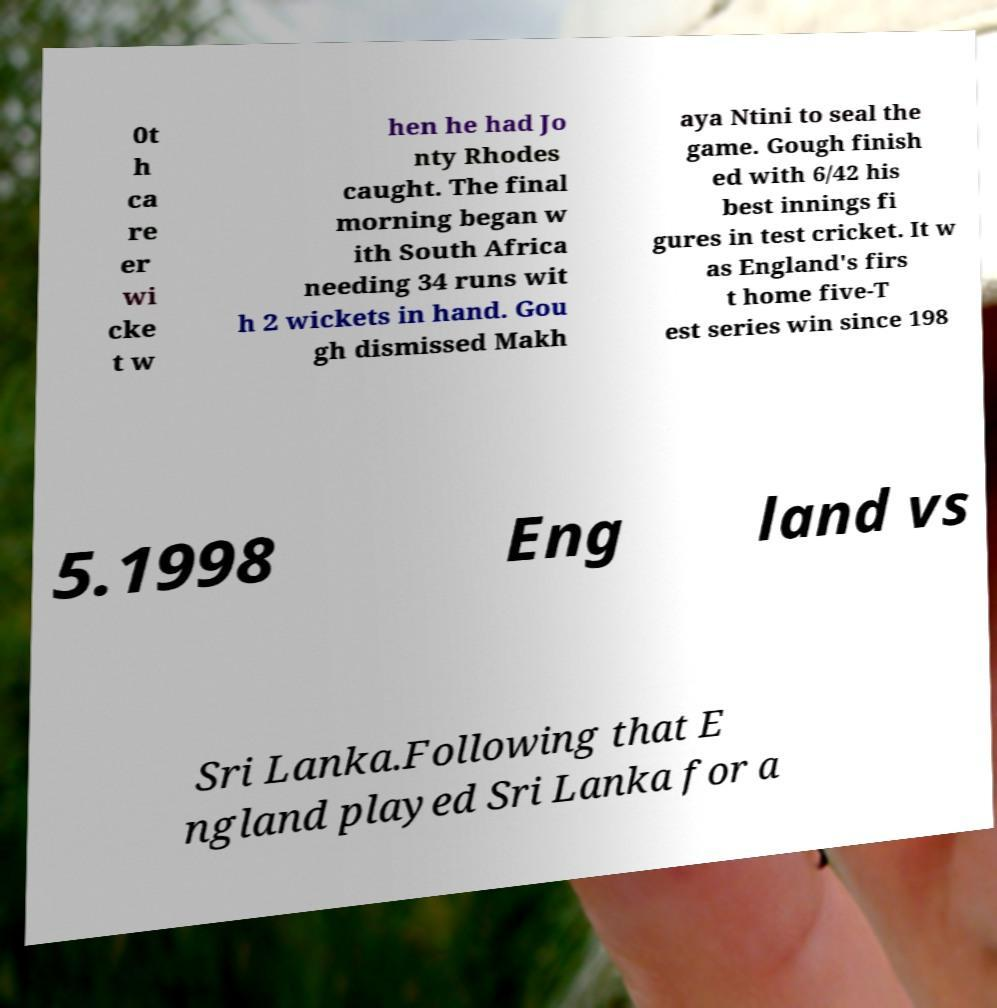Can you read and provide the text displayed in the image?This photo seems to have some interesting text. Can you extract and type it out for me? 0t h ca re er wi cke t w hen he had Jo nty Rhodes caught. The final morning began w ith South Africa needing 34 runs wit h 2 wickets in hand. Gou gh dismissed Makh aya Ntini to seal the game. Gough finish ed with 6/42 his best innings fi gures in test cricket. It w as England's firs t home five-T est series win since 198 5.1998 Eng land vs Sri Lanka.Following that E ngland played Sri Lanka for a 